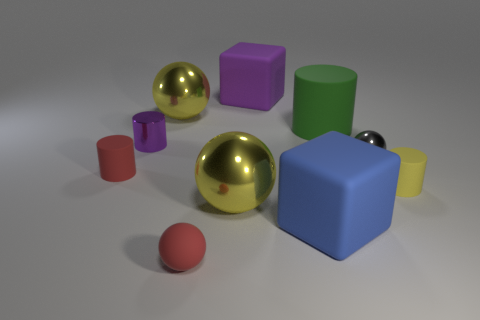Which objects in the image are spheres, and can you describe their colors? In the image, there are three spherical objects. One is a small red sphere, another is a reflective gold-colored sphere, and the third one is a smaller, silver-colored sphere. 